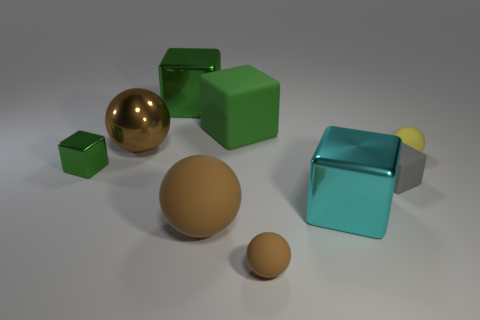What number of tiny things are made of the same material as the tiny brown sphere?
Ensure brevity in your answer.  2. How many tiny green objects are in front of the matte block in front of the yellow rubber sphere?
Provide a succinct answer. 0. Is the color of the big cube that is to the left of the big green matte thing the same as the small cube to the right of the tiny green shiny cube?
Make the answer very short. No. The matte thing that is behind the tiny green metallic object and on the right side of the large matte block has what shape?
Your answer should be compact. Sphere. Are there any tiny gray objects of the same shape as the tiny green shiny thing?
Provide a short and direct response. Yes. There is a green matte thing that is the same size as the cyan cube; what is its shape?
Provide a short and direct response. Cube. What material is the big cyan block?
Your answer should be compact. Metal. There is a matte sphere that is behind the tiny block right of the object that is on the left side of the large metallic ball; what size is it?
Your answer should be compact. Small. There is a tiny cube that is the same color as the big matte cube; what is its material?
Your answer should be compact. Metal. How many shiny objects are either tiny things or tiny yellow balls?
Provide a succinct answer. 1. 